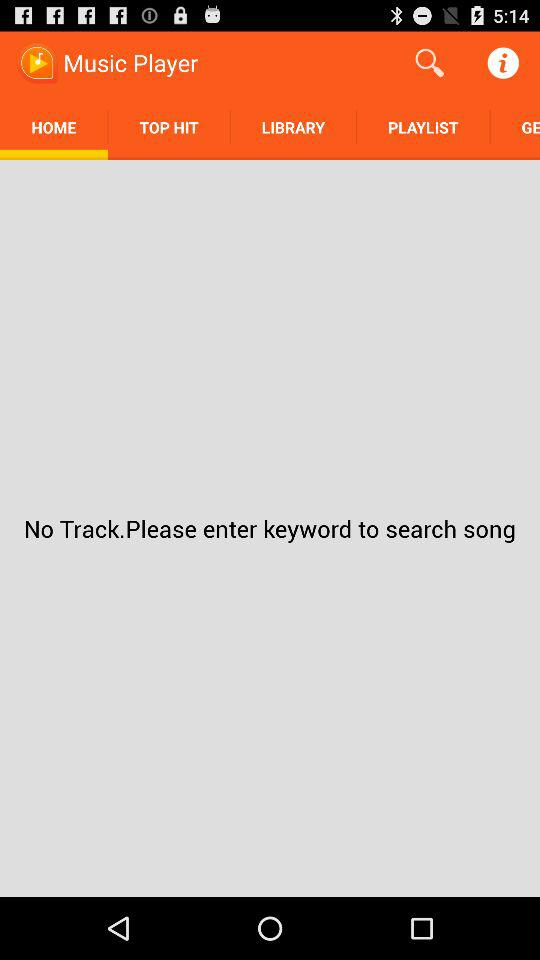Which songs are saved in the playlist?
When the provided information is insufficient, respond with <no answer>. <no answer> 